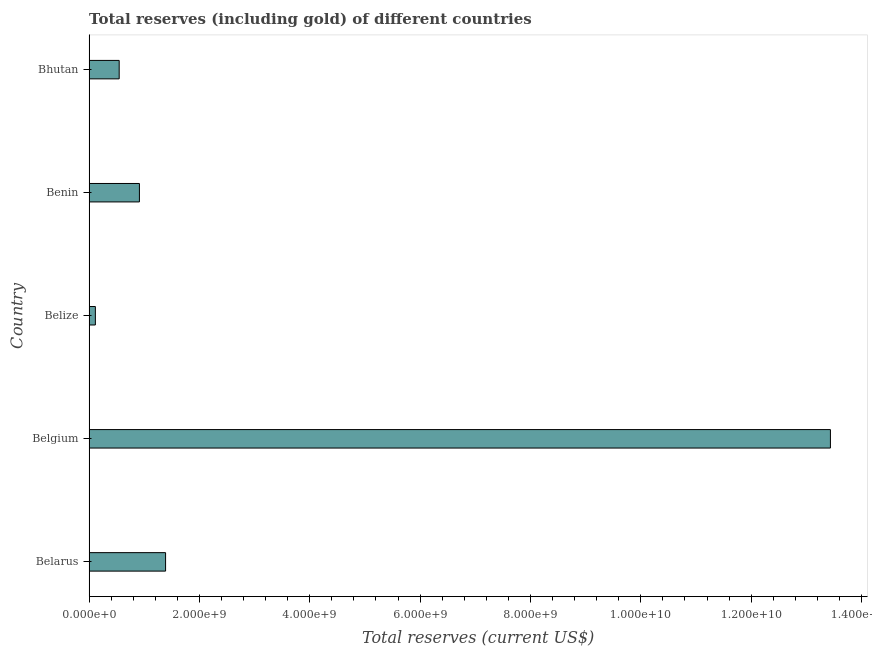What is the title of the graph?
Your answer should be very brief. Total reserves (including gold) of different countries. What is the label or title of the X-axis?
Ensure brevity in your answer.  Total reserves (current US$). What is the total reserves (including gold) in Belgium?
Give a very brief answer. 1.34e+1. Across all countries, what is the maximum total reserves (including gold)?
Your answer should be very brief. 1.34e+1. Across all countries, what is the minimum total reserves (including gold)?
Your answer should be very brief. 1.14e+08. In which country was the total reserves (including gold) maximum?
Keep it short and to the point. Belgium. In which country was the total reserves (including gold) minimum?
Provide a succinct answer. Belize. What is the sum of the total reserves (including gold)?
Provide a succinct answer. 1.64e+1. What is the difference between the total reserves (including gold) in Belize and Bhutan?
Your response must be concise. -4.32e+08. What is the average total reserves (including gold) per country?
Keep it short and to the point. 3.28e+09. What is the median total reserves (including gold)?
Your answer should be very brief. 9.12e+08. What is the ratio of the total reserves (including gold) in Belarus to that in Belgium?
Provide a succinct answer. 0.1. What is the difference between the highest and the second highest total reserves (including gold)?
Your answer should be compact. 1.21e+1. Is the sum of the total reserves (including gold) in Benin and Bhutan greater than the maximum total reserves (including gold) across all countries?
Make the answer very short. No. What is the difference between the highest and the lowest total reserves (including gold)?
Offer a terse response. 1.33e+1. Are all the bars in the graph horizontal?
Your answer should be very brief. Yes. What is the difference between two consecutive major ticks on the X-axis?
Your response must be concise. 2.00e+09. What is the Total reserves (current US$) in Belarus?
Make the answer very short. 1.39e+09. What is the Total reserves (current US$) in Belgium?
Provide a succinct answer. 1.34e+1. What is the Total reserves (current US$) in Belize?
Provide a short and direct response. 1.14e+08. What is the Total reserves (current US$) of Benin?
Provide a short and direct response. 9.12e+08. What is the Total reserves (current US$) in Bhutan?
Provide a succinct answer. 5.45e+08. What is the difference between the Total reserves (current US$) in Belarus and Belgium?
Offer a very short reply. -1.21e+1. What is the difference between the Total reserves (current US$) in Belarus and Belize?
Your response must be concise. 1.27e+09. What is the difference between the Total reserves (current US$) in Belarus and Benin?
Your answer should be very brief. 4.74e+08. What is the difference between the Total reserves (current US$) in Belarus and Bhutan?
Provide a short and direct response. 8.41e+08. What is the difference between the Total reserves (current US$) in Belgium and Belize?
Make the answer very short. 1.33e+1. What is the difference between the Total reserves (current US$) in Belgium and Benin?
Your answer should be compact. 1.25e+1. What is the difference between the Total reserves (current US$) in Belgium and Bhutan?
Provide a short and direct response. 1.29e+1. What is the difference between the Total reserves (current US$) in Belize and Benin?
Your response must be concise. -7.99e+08. What is the difference between the Total reserves (current US$) in Belize and Bhutan?
Keep it short and to the point. -4.32e+08. What is the difference between the Total reserves (current US$) in Benin and Bhutan?
Make the answer very short. 3.67e+08. What is the ratio of the Total reserves (current US$) in Belarus to that in Belgium?
Provide a short and direct response. 0.1. What is the ratio of the Total reserves (current US$) in Belarus to that in Belize?
Give a very brief answer. 12.19. What is the ratio of the Total reserves (current US$) in Belarus to that in Benin?
Offer a terse response. 1.52. What is the ratio of the Total reserves (current US$) in Belarus to that in Bhutan?
Offer a terse response. 2.54. What is the ratio of the Total reserves (current US$) in Belgium to that in Belize?
Keep it short and to the point. 118.15. What is the ratio of the Total reserves (current US$) in Belgium to that in Benin?
Your response must be concise. 14.73. What is the ratio of the Total reserves (current US$) in Belgium to that in Bhutan?
Make the answer very short. 24.64. What is the ratio of the Total reserves (current US$) in Belize to that in Benin?
Keep it short and to the point. 0.12. What is the ratio of the Total reserves (current US$) in Belize to that in Bhutan?
Make the answer very short. 0.21. What is the ratio of the Total reserves (current US$) in Benin to that in Bhutan?
Offer a very short reply. 1.67. 